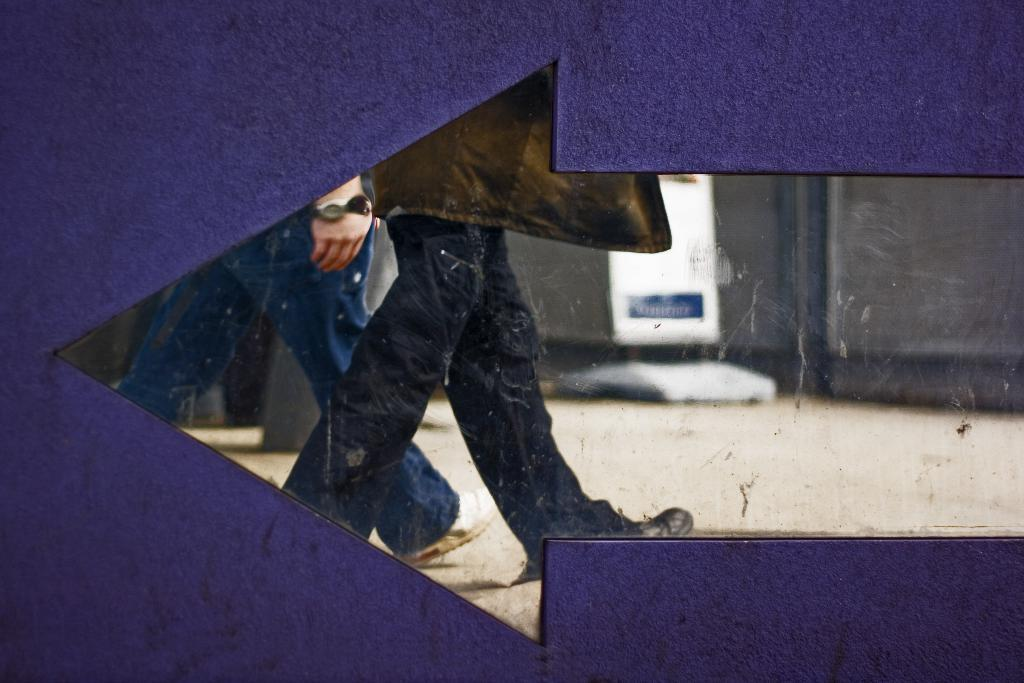What is the main object in the image? There is a signboard in the image. Can you describe what is happening in the middle of the image? There are legs of two persons in the middle of the image. What type of object might be associated with the legs in the image? It appears to be a glass in the image. What type of sock is the pen wearing in the image? There is no sock or pen present in the image. 